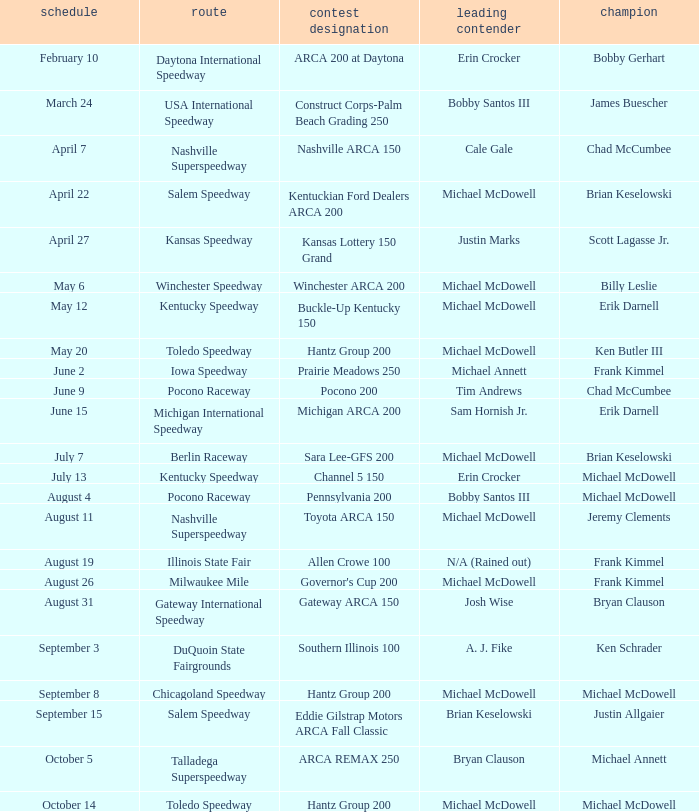Tell me the event name for michael mcdowell and billy leslie Winchester ARCA 200. 